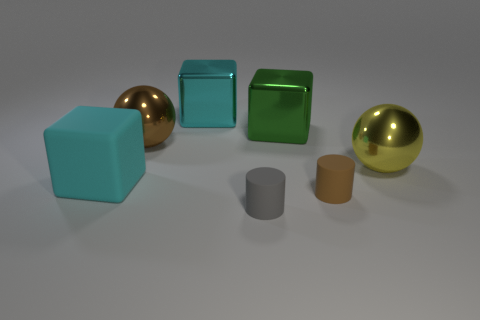Add 1 big purple matte cylinders. How many objects exist? 8 Subtract all balls. How many objects are left? 5 Add 4 brown cylinders. How many brown cylinders exist? 5 Subtract 1 brown spheres. How many objects are left? 6 Subtract all big green objects. Subtract all large metal cubes. How many objects are left? 4 Add 3 large cyan shiny blocks. How many large cyan shiny blocks are left? 4 